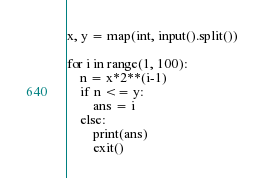<code> <loc_0><loc_0><loc_500><loc_500><_Python_>x, y = map(int, input().split())

for i in range(1, 100):
    n = x*2**(i-1)
    if n <= y:
        ans = i
    else:
        print(ans)
        exit()
</code> 